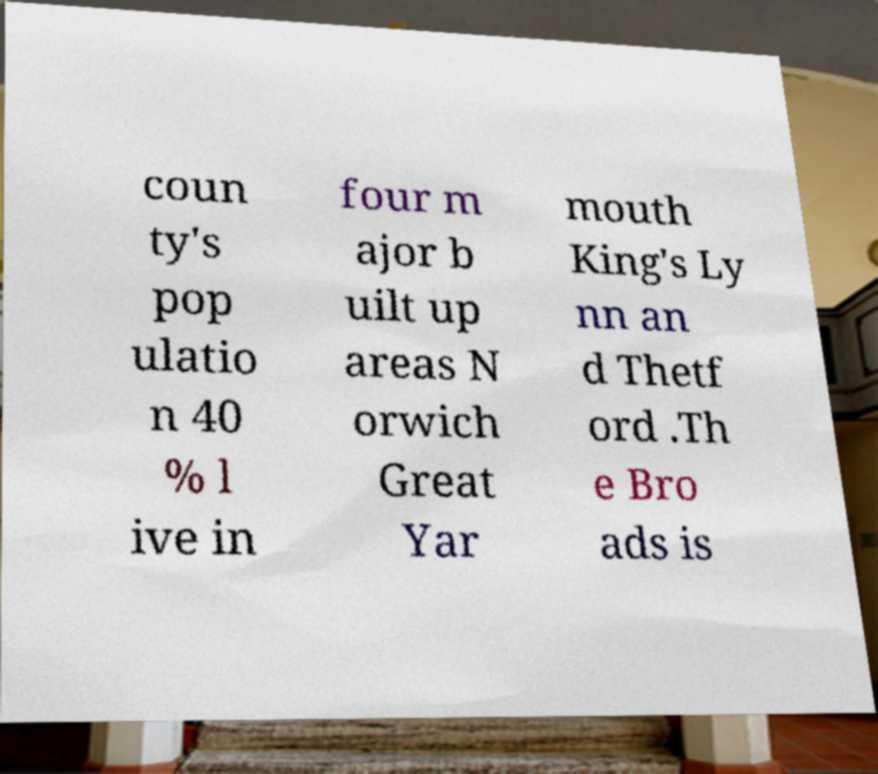Could you assist in decoding the text presented in this image and type it out clearly? coun ty's pop ulatio n 40 % l ive in four m ajor b uilt up areas N orwich Great Yar mouth King's Ly nn an d Thetf ord .Th e Bro ads is 